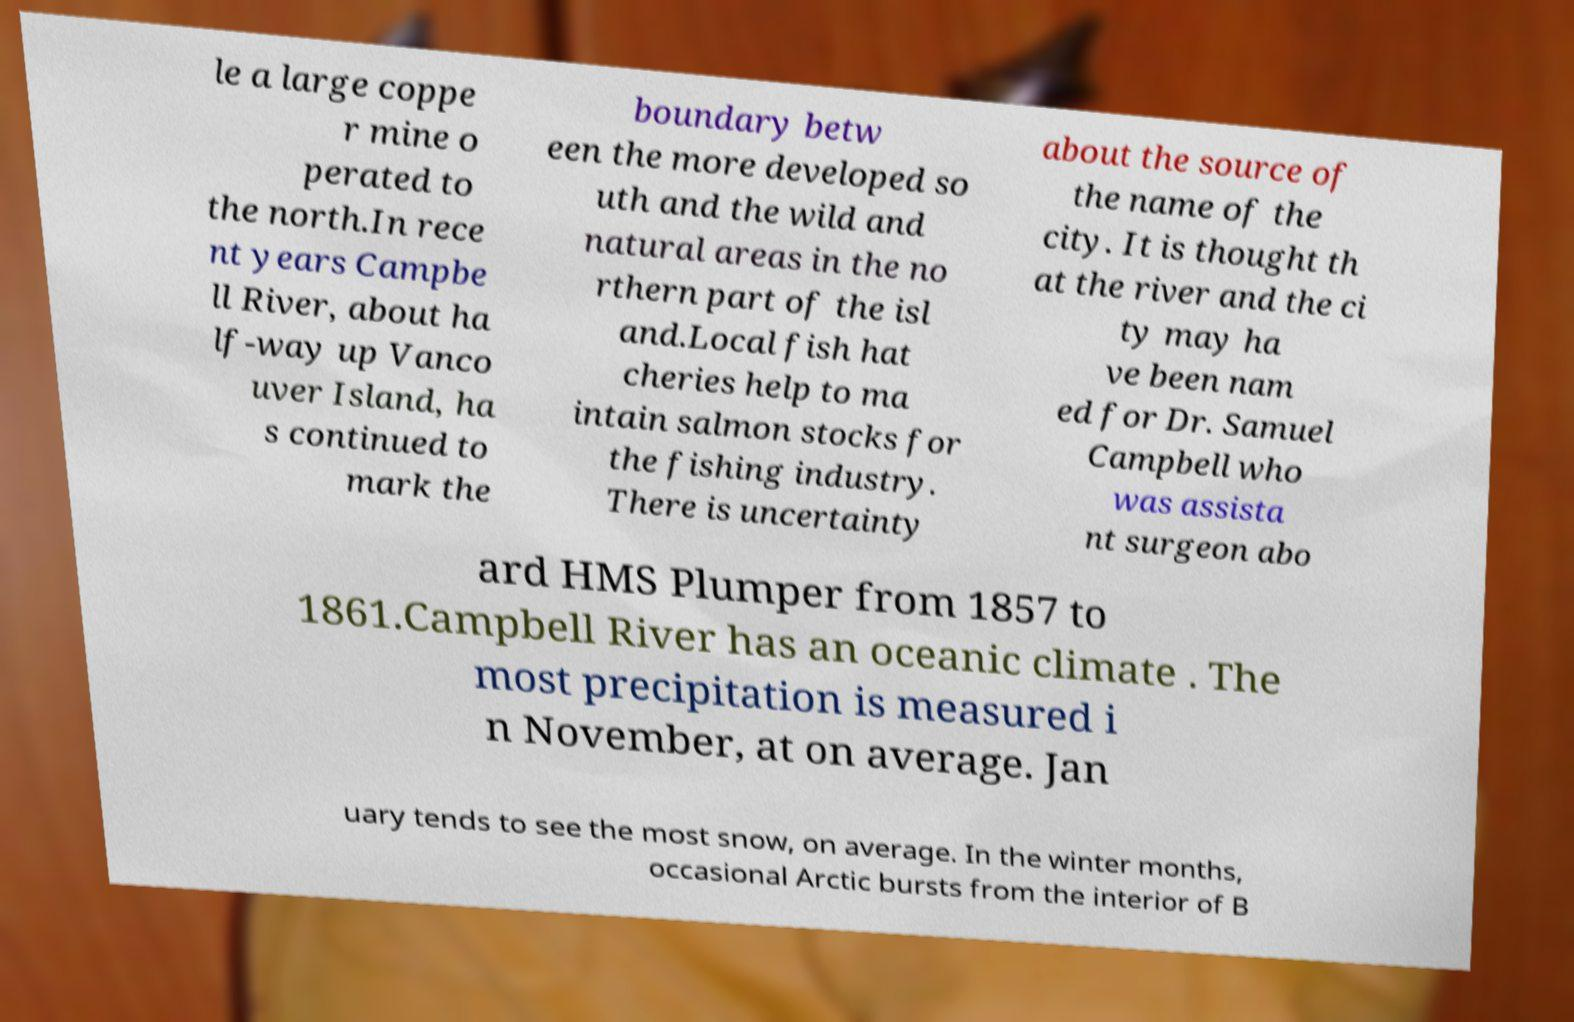Could you extract and type out the text from this image? le a large coppe r mine o perated to the north.In rece nt years Campbe ll River, about ha lf-way up Vanco uver Island, ha s continued to mark the boundary betw een the more developed so uth and the wild and natural areas in the no rthern part of the isl and.Local fish hat cheries help to ma intain salmon stocks for the fishing industry. There is uncertainty about the source of the name of the city. It is thought th at the river and the ci ty may ha ve been nam ed for Dr. Samuel Campbell who was assista nt surgeon abo ard HMS Plumper from 1857 to 1861.Campbell River has an oceanic climate . The most precipitation is measured i n November, at on average. Jan uary tends to see the most snow, on average. In the winter months, occasional Arctic bursts from the interior of B 